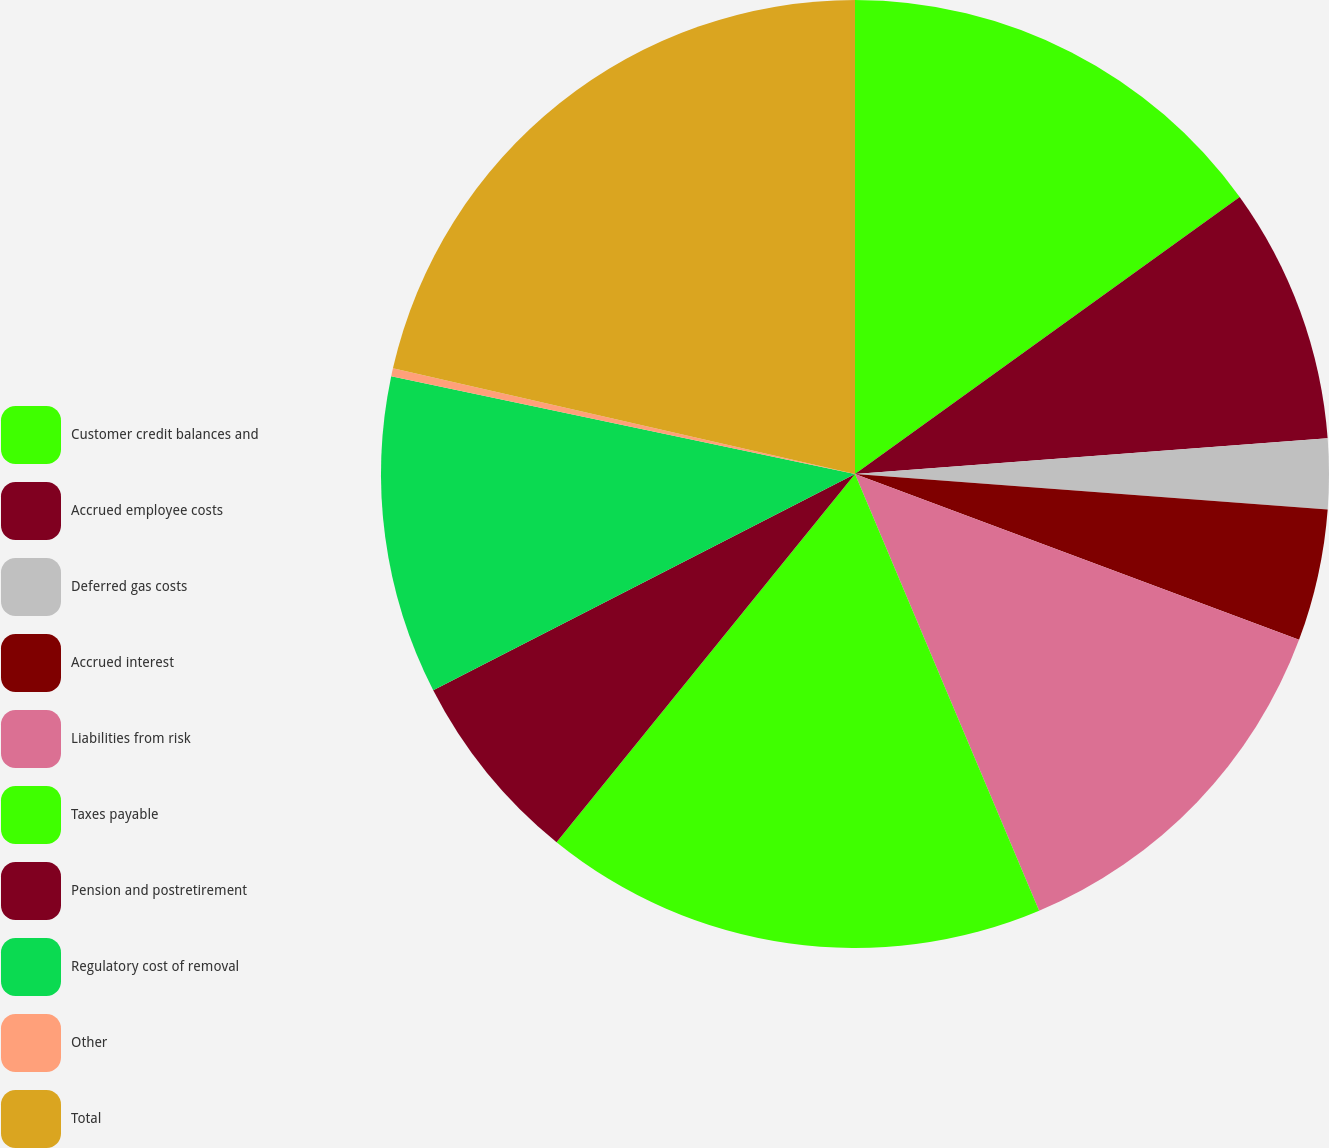Convert chart. <chart><loc_0><loc_0><loc_500><loc_500><pie_chart><fcel>Customer credit balances and<fcel>Accrued employee costs<fcel>Deferred gas costs<fcel>Accrued interest<fcel>Liabilities from risk<fcel>Taxes payable<fcel>Pension and postretirement<fcel>Regulatory cost of removal<fcel>Other<fcel>Total<nl><fcel>15.07%<fcel>8.73%<fcel>2.39%<fcel>4.5%<fcel>12.96%<fcel>17.19%<fcel>6.62%<fcel>10.85%<fcel>0.27%<fcel>21.42%<nl></chart> 